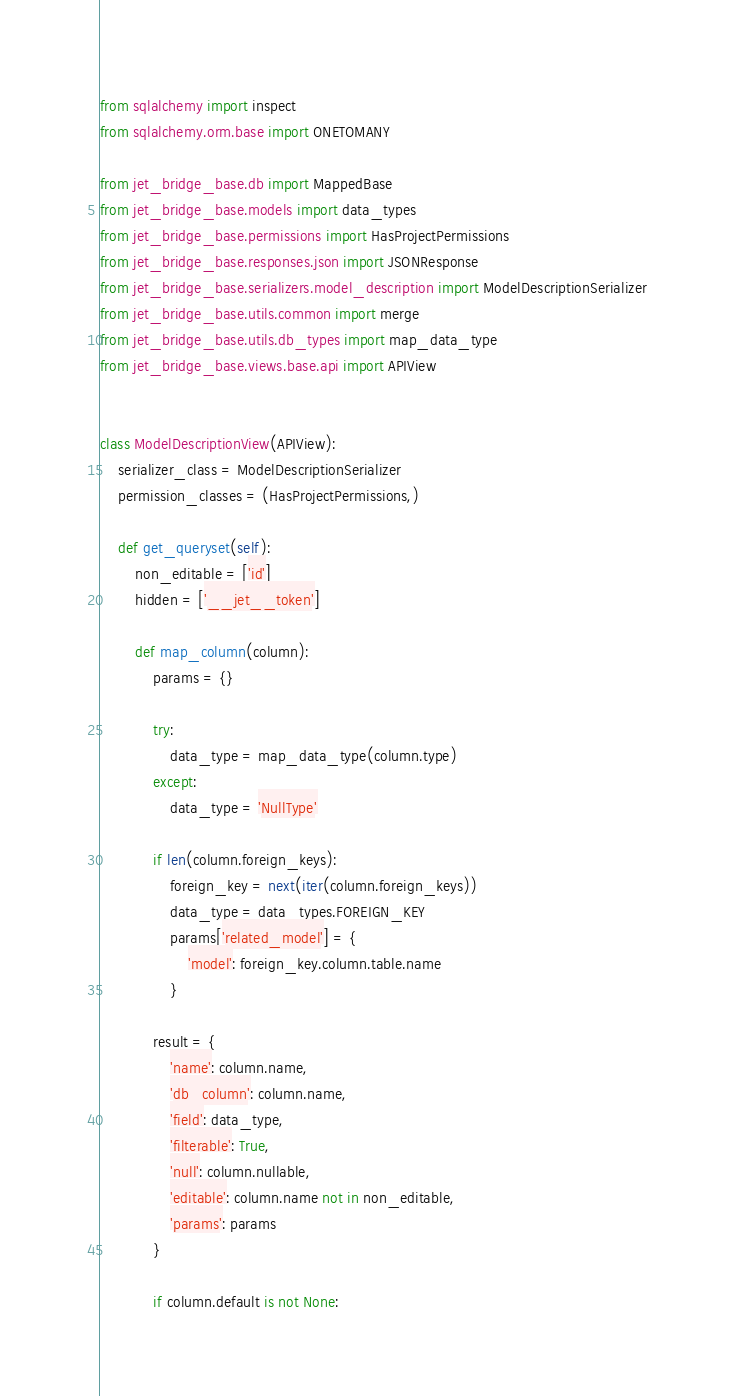<code> <loc_0><loc_0><loc_500><loc_500><_Python_>from sqlalchemy import inspect
from sqlalchemy.orm.base import ONETOMANY

from jet_bridge_base.db import MappedBase
from jet_bridge_base.models import data_types
from jet_bridge_base.permissions import HasProjectPermissions
from jet_bridge_base.responses.json import JSONResponse
from jet_bridge_base.serializers.model_description import ModelDescriptionSerializer
from jet_bridge_base.utils.common import merge
from jet_bridge_base.utils.db_types import map_data_type
from jet_bridge_base.views.base.api import APIView


class ModelDescriptionView(APIView):
    serializer_class = ModelDescriptionSerializer
    permission_classes = (HasProjectPermissions,)

    def get_queryset(self):
        non_editable = ['id']
        hidden = ['__jet__token']

        def map_column(column):
            params = {}

            try:
                data_type = map_data_type(column.type)
            except:
                data_type = 'NullType'

            if len(column.foreign_keys):
                foreign_key = next(iter(column.foreign_keys))
                data_type = data_types.FOREIGN_KEY
                params['related_model'] = {
                    'model': foreign_key.column.table.name
                }

            result = {
                'name': column.name,
                'db_column': column.name,
                'field': data_type,
                'filterable': True,
                'null': column.nullable,
                'editable': column.name not in non_editable,
                'params': params
            }

            if column.default is not None:</code> 